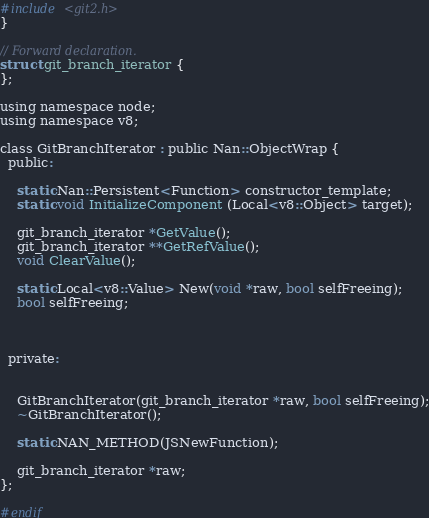Convert code to text. <code><loc_0><loc_0><loc_500><loc_500><_C_>#include <git2.h>
}

// Forward declaration.
struct git_branch_iterator {
};

using namespace node;
using namespace v8;

class GitBranchIterator : public Nan::ObjectWrap {
  public:

    static Nan::Persistent<Function> constructor_template;
    static void InitializeComponent (Local<v8::Object> target);

    git_branch_iterator *GetValue();
    git_branch_iterator **GetRefValue();
    void ClearValue();

    static Local<v8::Value> New(void *raw, bool selfFreeing);
    bool selfFreeing;

 

  private:


    GitBranchIterator(git_branch_iterator *raw, bool selfFreeing);
    ~GitBranchIterator();
 
    static NAN_METHOD(JSNewFunction);

    git_branch_iterator *raw;
};

#endif
</code> 